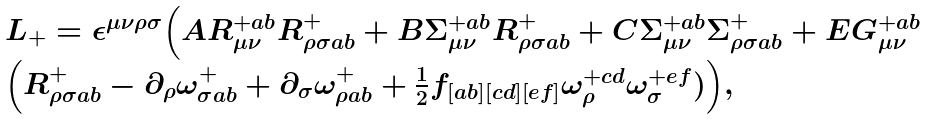Convert formula to latex. <formula><loc_0><loc_0><loc_500><loc_500>\begin{array} { l l } L _ { + } = \epsilon ^ { \mu \nu \rho \sigma } \Big ( A R ^ { + a b } _ { \mu \nu } R ^ { + } _ { \rho \sigma a b } + B \Sigma ^ { + a b } _ { \mu \nu } R ^ { + } _ { \rho \sigma a b } + C \Sigma ^ { + a b } _ { \mu \nu } \Sigma ^ { + } _ { \rho \sigma a b } + E G ^ { + a b } _ { \mu \nu } \\ \Big ( R ^ { + } _ { \rho \sigma a b } - \partial _ { \rho } \omega ^ { + } _ { \sigma a b } + \partial _ { \sigma } \omega ^ { + } _ { \rho a b } + \frac { 1 } { 2 } f _ { [ a b ] [ c d ] [ e f ] } \omega ^ { + c d } _ { \rho } \omega _ { \sigma } ^ { + e f } ) \Big ) , \end{array}</formula> 